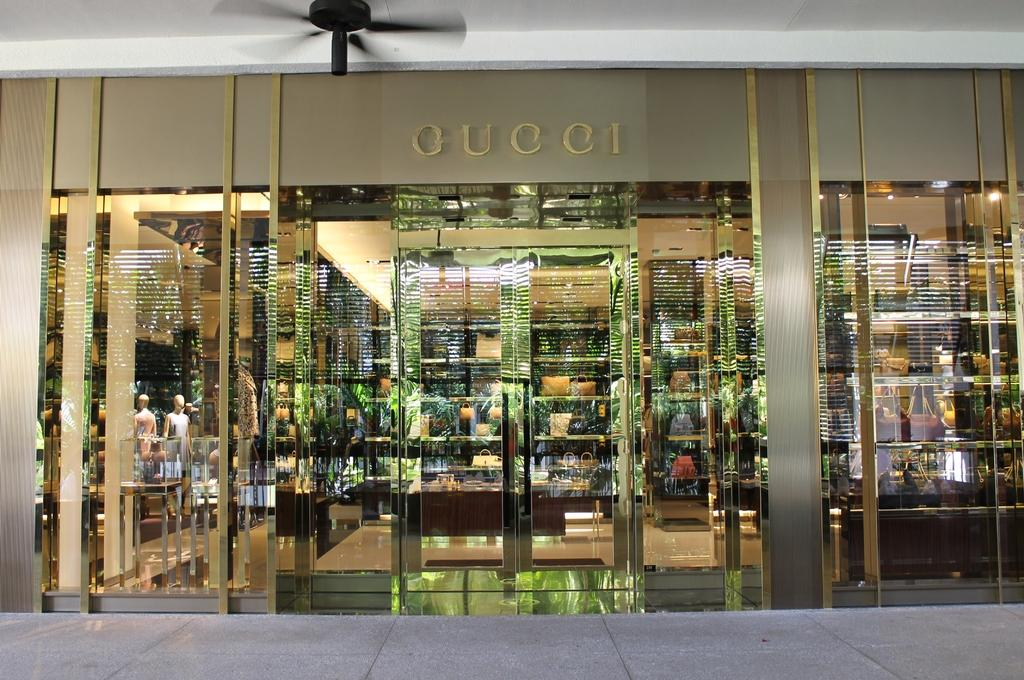What type of structure is present in the image? There is a building in the image. Is there any writing or text on the building? Yes, there is text written on the building. Can you describe any other objects or features visible in the image? There is a fan visible at the top of the image. How many clams are being used to wash the building in the image? There are no clams present in the image, and they are not being used for washing the building. 